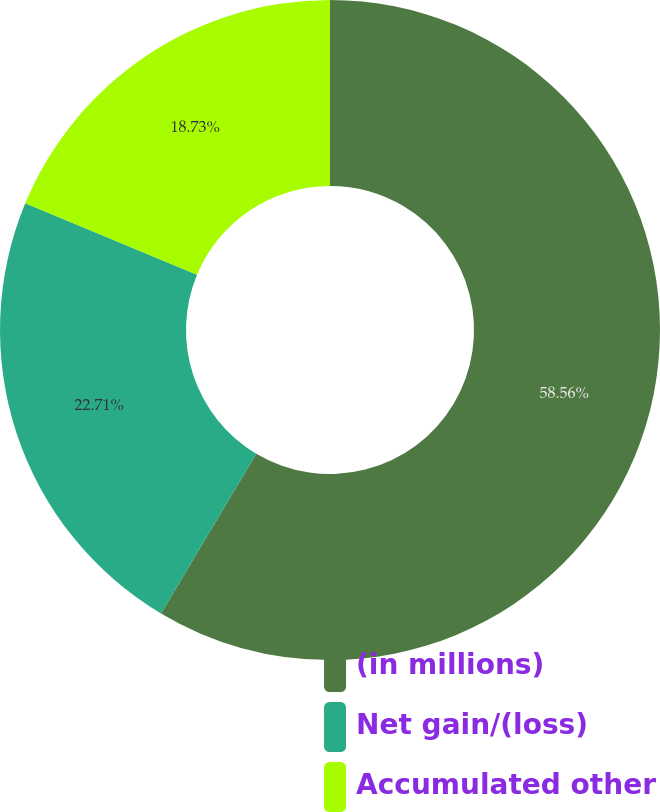<chart> <loc_0><loc_0><loc_500><loc_500><pie_chart><fcel>(in millions)<fcel>Net gain/(loss)<fcel>Accumulated other<nl><fcel>58.55%<fcel>22.71%<fcel>18.73%<nl></chart> 